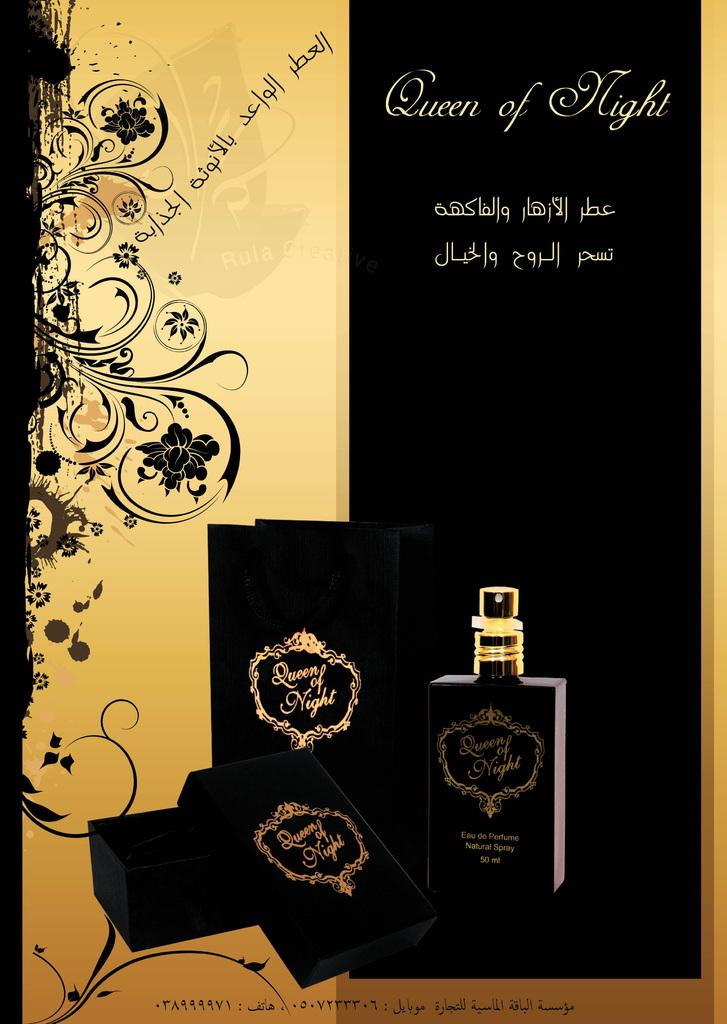<image>
Give a short and clear explanation of the subsequent image. A magazine style ad for Queen of Night perfume. 